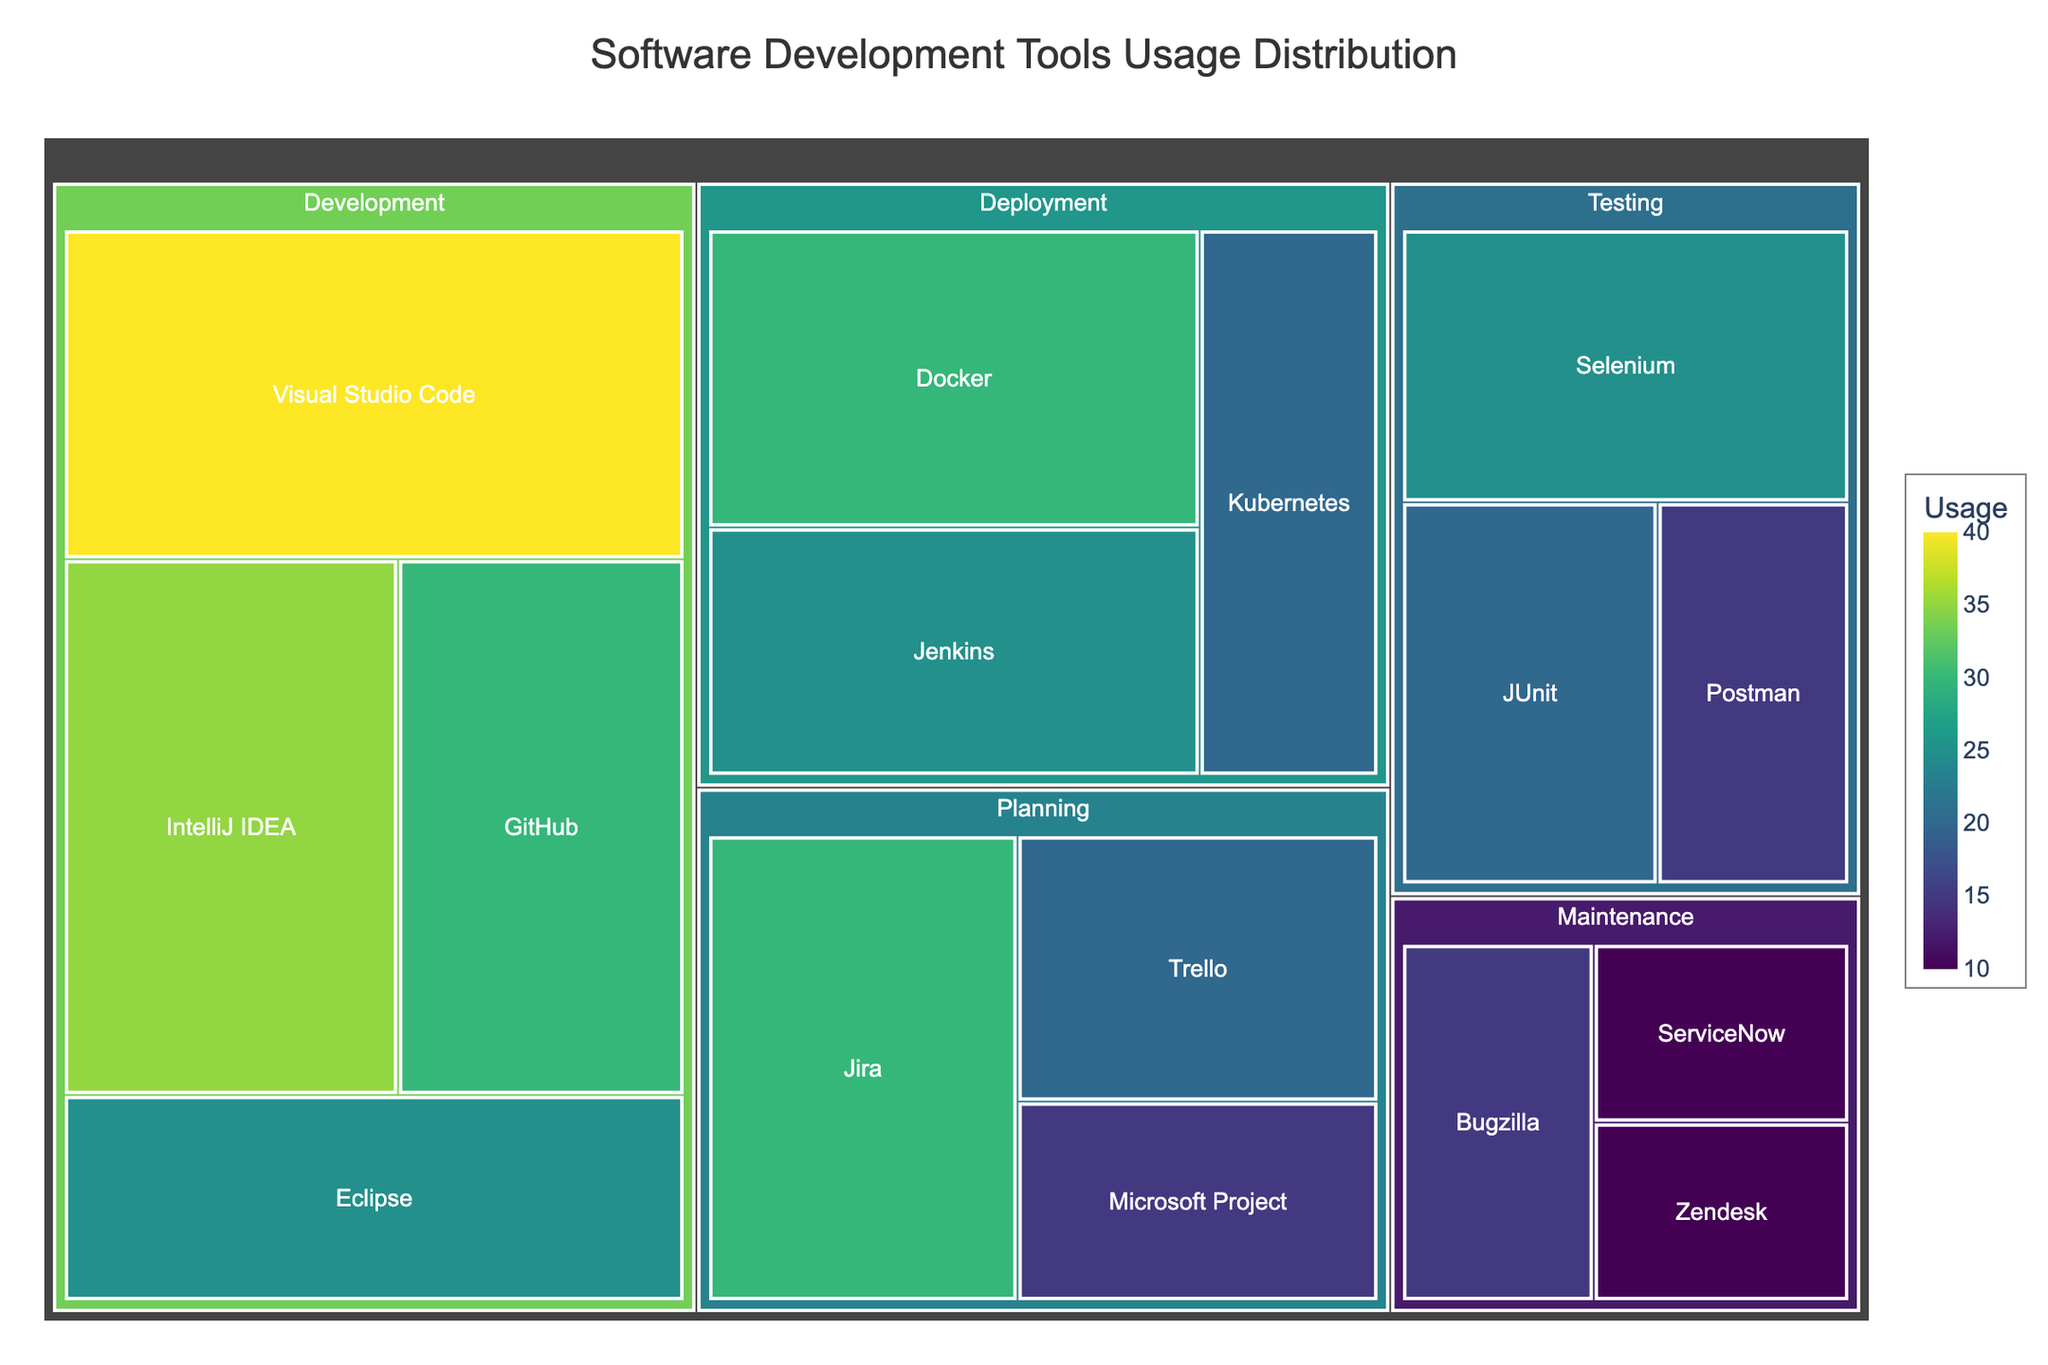What's the title of the Treemap figure? The title is displayed prominently at the top of the figure. This is often one of the first pieces of information visible to help viewers understand the theme of the chart.
Answer: Software Development Tools Usage Distribution How many tools are listed under the Development stage? Counting each tool listed under the Development stage in the chart reveals the total number of tools.
Answer: 4 What is the most used tool in the Testing stage? By looking at the size of the tiles within the Testing stage, one can identify the tool with the largest tile, indicating the highest usage.
Answer: Selenium Which stage has the least number of tools, and how many are there? Observing each stage, count the number of tools listed within each to determine the one with the least number.
Answer: Maintenance; 3 What tool has the highest usage across all stages, and what is its usage value? By comparing the sizes of all tiles in the figure, identify the largest one, which represents the tool with the highest usage.
Answer: Visual Studio Code; 40 What is the cumulative usage of deployment tools? Add the usage values of all tools listed under the Deployment stage.
Answer: Docker (30) + Jenkins (25) + Kubernetes (20) = 75 Which stage shows the highest diversity of tools, and how can you tell? Identify the stage with the most distinct tiles/tools present in it.
Answer: Development; 4 tools Compare the total usage of tools in Planning and Testing stages. Which one is higher and by how much? Sum up the usage of all tools in both stages and compare the totals to find the difference.
Answer: Planning: 30 + 20 + 15 = 65, Testing: 25 + 20 + 15 = 60; Planning is higher by 5 What is the average usage of the tools in the Maintenance stage? Add the usage values of the tools in Maintenance and divide by the number of tools.
Answer: (15 + 10 + 10) / 3 = 35 / 3 ≈ 11.67 Is all data in the chart represented by unique colors? By observing the color coding within the figure, one can determine if each tile has a distinct color or if some share the same hue.
Answer: Yes 